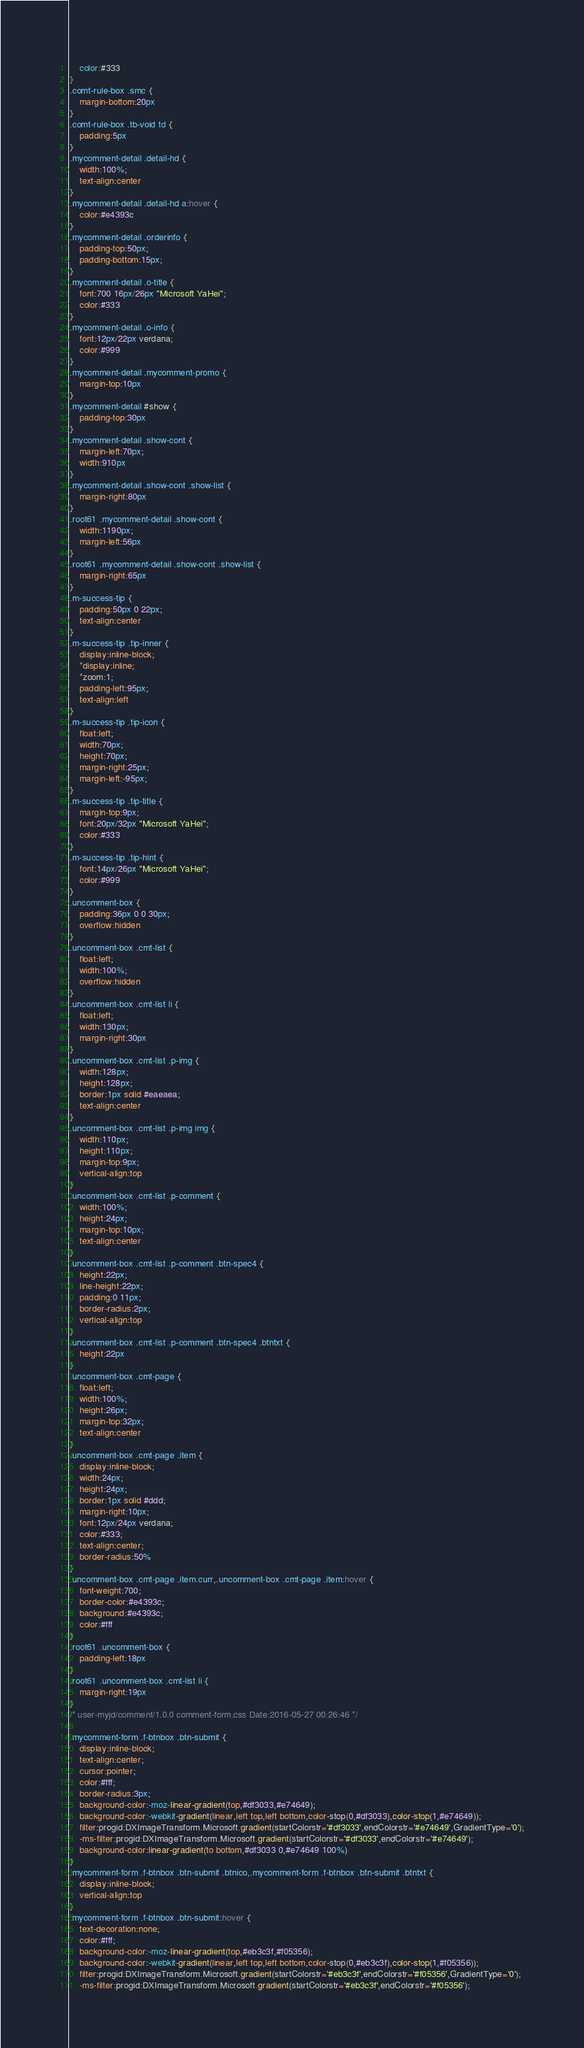<code> <loc_0><loc_0><loc_500><loc_500><_CSS_>	color:#333
}
.comt-rule-box .smc {
	margin-bottom:20px
}
.comt-rule-box .tb-void td {
	padding:5px
}
.mycomment-detail .detail-hd {
	width:100%;
	text-align:center
}
.mycomment-detail .detail-hd a:hover {
	color:#e4393c
}
.mycomment-detail .orderinfo {
	padding-top:50px;
	padding-bottom:15px;
}
.mycomment-detail .o-title {
	font:700 16px/26px "Microsoft YaHei";
	color:#333
}
.mycomment-detail .o-info {
	font:12px/22px verdana;
	color:#999
}
.mycomment-detail .mycomment-promo {
	margin-top:10px
}
.mycomment-detail #show {
	padding-top:30px
}
.mycomment-detail .show-cont {
	margin-left:70px;
	width:910px
}
.mycomment-detail .show-cont .show-list {
	margin-right:80px
}
.root61 .mycomment-detail .show-cont {
	width:1190px;
	margin-left:56px
}
.root61 .mycomment-detail .show-cont .show-list {
	margin-right:65px
}
.m-success-tip {
	padding:50px 0 22px;
	text-align:center
}
.m-success-tip .tip-inner {
	display:inline-block;
	*display:inline;
	*zoom:1;
	padding-left:95px;
	text-align:left
}
.m-success-tip .tip-icon {
	float:left;
	width:70px;
	height:70px;
	margin-right:25px;
	margin-left:-95px;
}
.m-success-tip .tip-title {
	margin-top:9px;
	font:20px/32px "Microsoft YaHei";
	color:#333
}
.m-success-tip .tip-hint {
	font:14px/26px "Microsoft YaHei";
	color:#999
}
.uncomment-box {
	padding:36px 0 0 30px;
	overflow:hidden
}
.uncomment-box .cmt-list {
	float:left;
	width:100%;
	overflow:hidden
}
.uncomment-box .cmt-list li {
	float:left;
	width:130px;
	margin-right:30px
}
.uncomment-box .cmt-list .p-img {
	width:128px;
	height:128px;
	border:1px solid #eaeaea;
	text-align:center
}
.uncomment-box .cmt-list .p-img img {
	width:110px;
	height:110px;
	margin-top:9px;
	vertical-align:top
}
.uncomment-box .cmt-list .p-comment {
	width:100%;
	height:24px;
	margin-top:10px;
	text-align:center
}
.uncomment-box .cmt-list .p-comment .btn-spec4 {
	height:22px;
	line-height:22px;
	padding:0 11px;
	border-radius:2px;
	vertical-align:top
}
.uncomment-box .cmt-list .p-comment .btn-spec4 .btntxt {
	height:22px
}
.uncomment-box .cmt-page {
	float:left;
	width:100%;
	height:26px;
	margin-top:32px;
	text-align:center
}
.uncomment-box .cmt-page .item {
	display:inline-block;
	width:24px;
	height:24px;
	border:1px solid #ddd;
	margin-right:10px;
	font:12px/24px verdana;
	color:#333;
	text-align:center;
	border-radius:50%
}
.uncomment-box .cmt-page .item.curr,.uncomment-box .cmt-page .item:hover {
	font-weight:700;
	border-color:#e4393c;
	background:#e4393c;
	color:#fff
}
.root61 .uncomment-box {
	padding-left:18px
}
.root61 .uncomment-box .cmt-list li {
	margin-right:19px
}
/* user-myjd/comment/1.0.0 comment-form.css Date:2016-05-27 00:26:46 */

.mycomment-form .f-btnbox .btn-submit {
	display:inline-block;
	text-align:center;
	cursor:pointer;
	color:#fff;
	border-radius:3px;
	background-color:-moz-linear-gradient(top,#df3033,#e74649);
	background-color:-webkit-gradient(linear,left top,left bottom,color-stop(0,#df3033),color-stop(1,#e74649));
	filter:progid:DXImageTransform.Microsoft.gradient(startColorstr='#df3033',endColorstr='#e74649',GradientType='0');
	-ms-filter:progid:DXImageTransform.Microsoft.gradient(startColorstr='#df3033',endColorstr='#e74649');
	background-color:linear-gradient(to bottom,#df3033 0,#e74649 100%)
}
.mycomment-form .f-btnbox .btn-submit .btnico,.mycomment-form .f-btnbox .btn-submit .btntxt {
	display:inline-block;
	vertical-align:top
}
.mycomment-form .f-btnbox .btn-submit:hover {
	text-decoration:none;
	color:#fff;
	background-color:-moz-linear-gradient(top,#eb3c3f,#f05356);
	background-color:-webkit-gradient(linear,left top,left bottom,color-stop(0,#eb3c3f),color-stop(1,#f05356));
	filter:progid:DXImageTransform.Microsoft.gradient(startColorstr='#eb3c3f',endColorstr='#f05356',GradientType='0');
	-ms-filter:progid:DXImageTransform.Microsoft.gradient(startColorstr='#eb3c3f',endColorstr='#f05356');</code> 